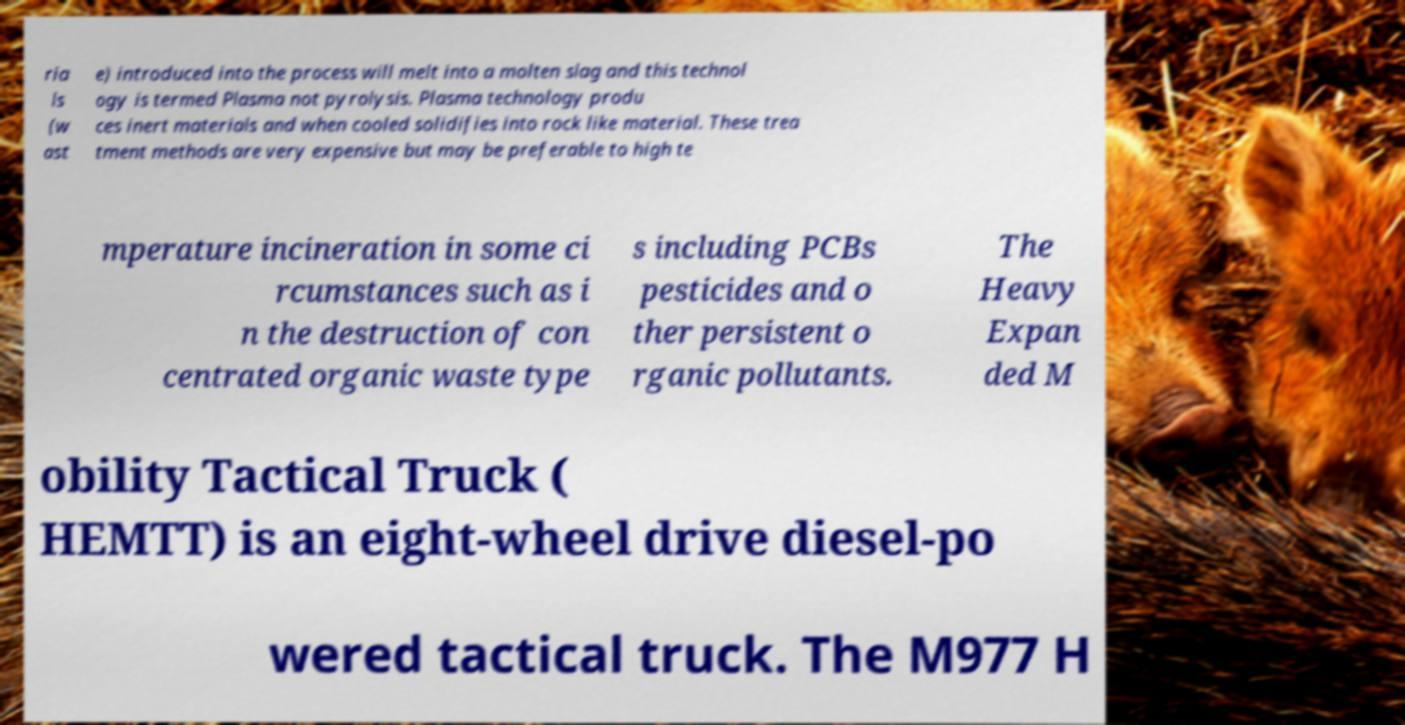Please identify and transcribe the text found in this image. ria ls (w ast e) introduced into the process will melt into a molten slag and this technol ogy is termed Plasma not pyrolysis. Plasma technology produ ces inert materials and when cooled solidifies into rock like material. These trea tment methods are very expensive but may be preferable to high te mperature incineration in some ci rcumstances such as i n the destruction of con centrated organic waste type s including PCBs pesticides and o ther persistent o rganic pollutants. The Heavy Expan ded M obility Tactical Truck ( HEMTT) is an eight-wheel drive diesel-po wered tactical truck. The M977 H 